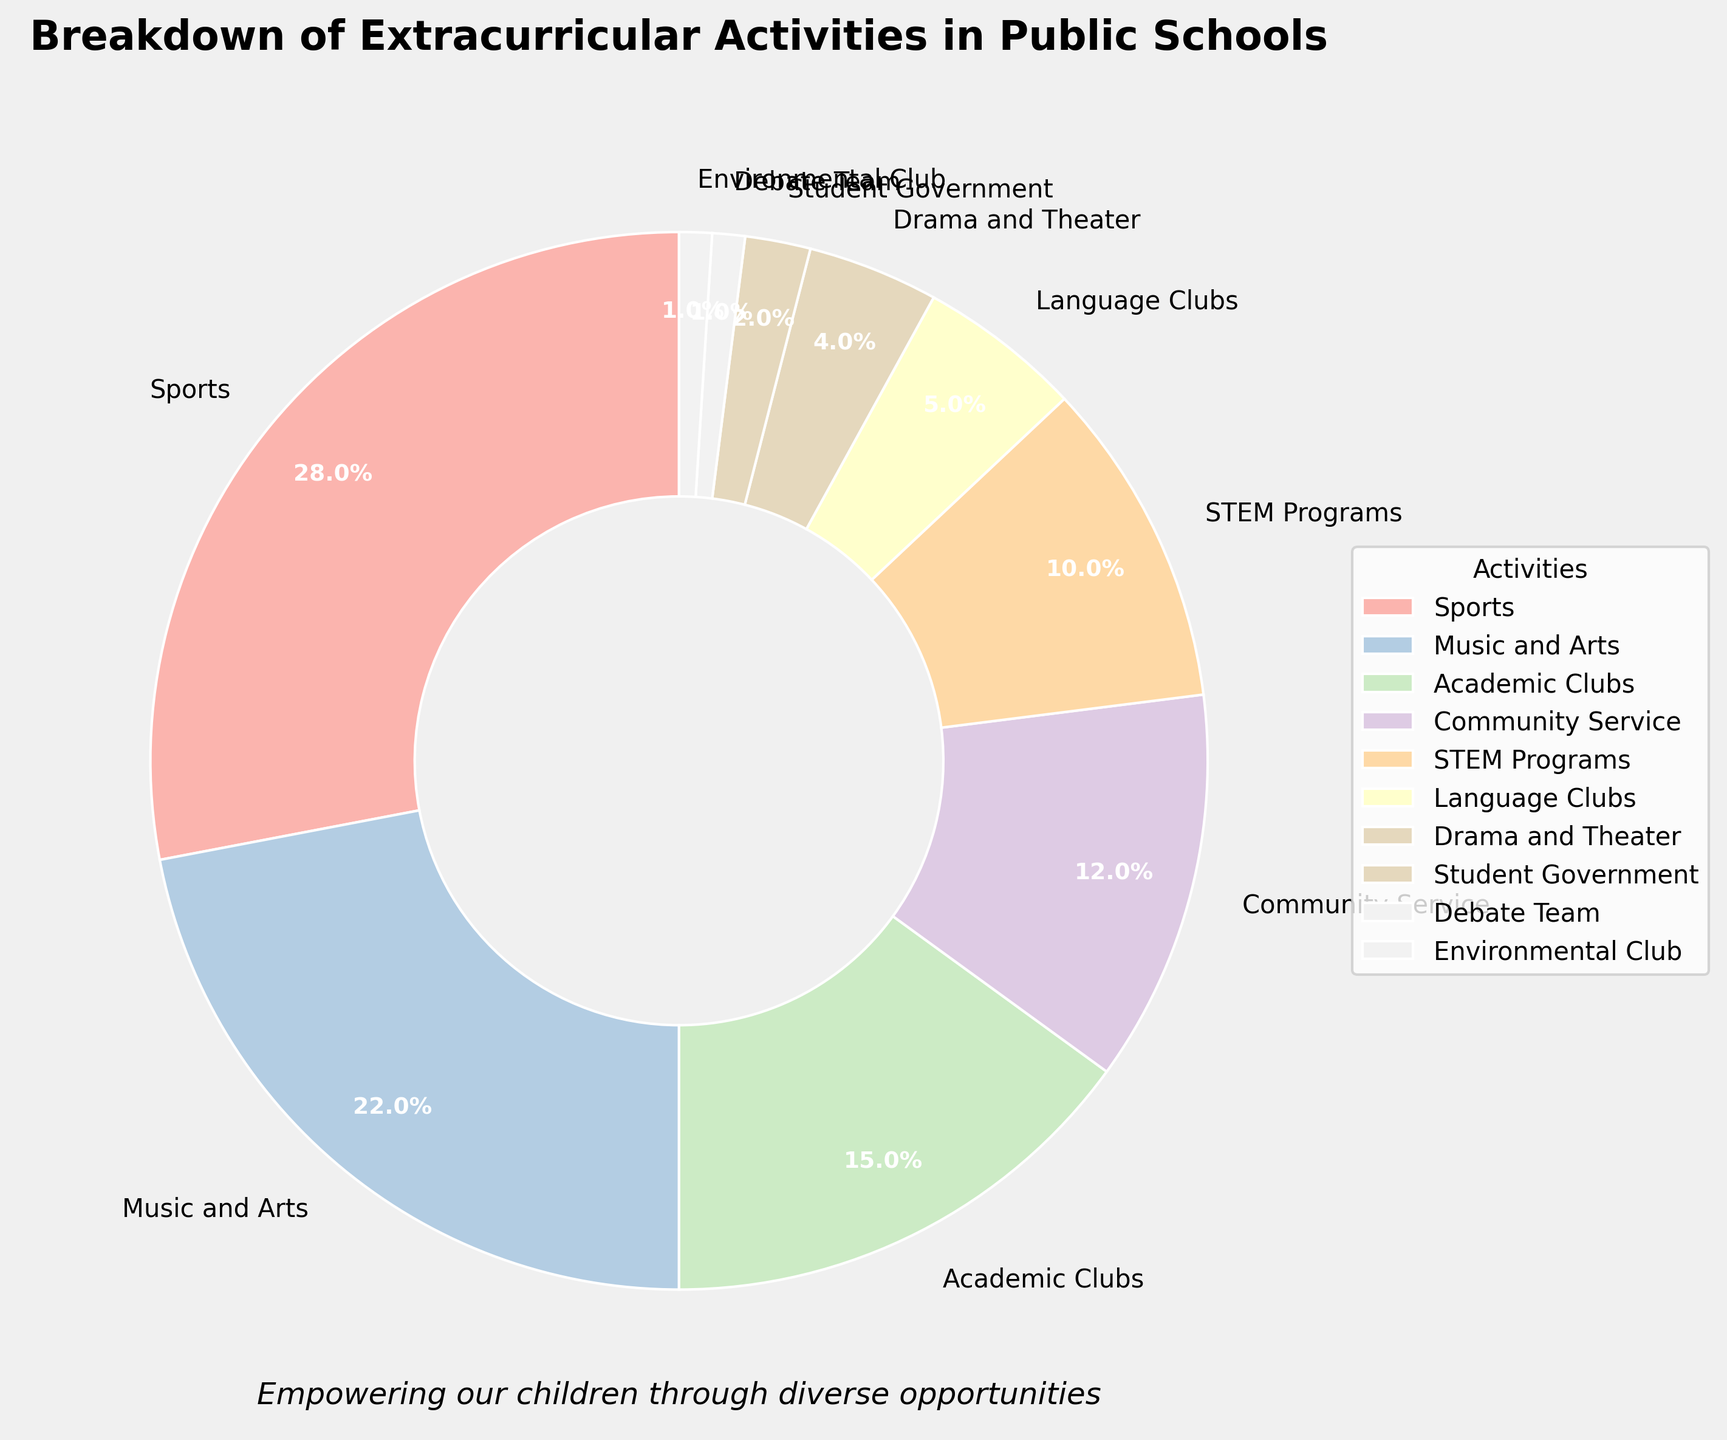Which activity has the highest percentage of participation? By observing the pie chart, the largest wedge represents Sports.
Answer: Sports What is the combined percentage of Music and Arts and STEM Programs? Music and Arts have 22%, and STEM Programs have 10%. Adding them together: 22 + 10 = 32%
Answer: 32% How does the percentage of Academic Clubs compare to Community Service? The pie chart shows Academic Clubs at 15% and Community Service at 12%. Therefore, Academic Clubs are higher.
Answer: Academic Clubs are higher Which activities occupy the smallest portions of the pie chart? By looking at the smallest wedges, they are Student Government, Debate Team, and Environmental Club with 2%, 1%, and 1% respectively.
Answer: Student Government, Debate Team, Environmental Club How much greater is the percentage of Sports compared to Drama and Theater? Sports is at 28%, and Drama and Theater is at 4%. Subtracting the two: 28 - 4 = 24%
Answer: 24% What is the total percentage of activities related to creative arts (Music and Arts + Drama and Theater)? Music and Arts is 22%, Drama and Theater is 4%. Adding them together: 22 + 4 = 26%
Answer: 26% What is the average percentage for Sports, Music and Arts, and Academic Clubs? (28 + 22 + 15) / 3 = 65 / 3 ≈ 21.67%
Answer: ~21.67% Which has a higher percentage: Language Clubs or Environmental Club? Language Clubs have 5%, while the Environmental Club has 1%. Language Clubs are higher.
Answer: Language Clubs are higher What is the difference in percentage between Community Service and Student Government? Community Service has 12%, Student Government has 2%. Subtract them: 12 - 2 = 10%
Answer: 10% If you combine the categories with less than 10% participation, what total percentage do they form? Activities with less than 10% are STEM Programs (10%), Language Clubs (5%), Drama and Theater (4%), Student Government (2%), Debate Team (1%), and Environmental Club (1%). Sum: 10 + 5 + 4 + 2 + 1 + 1 = 23%
Answer: 23% 